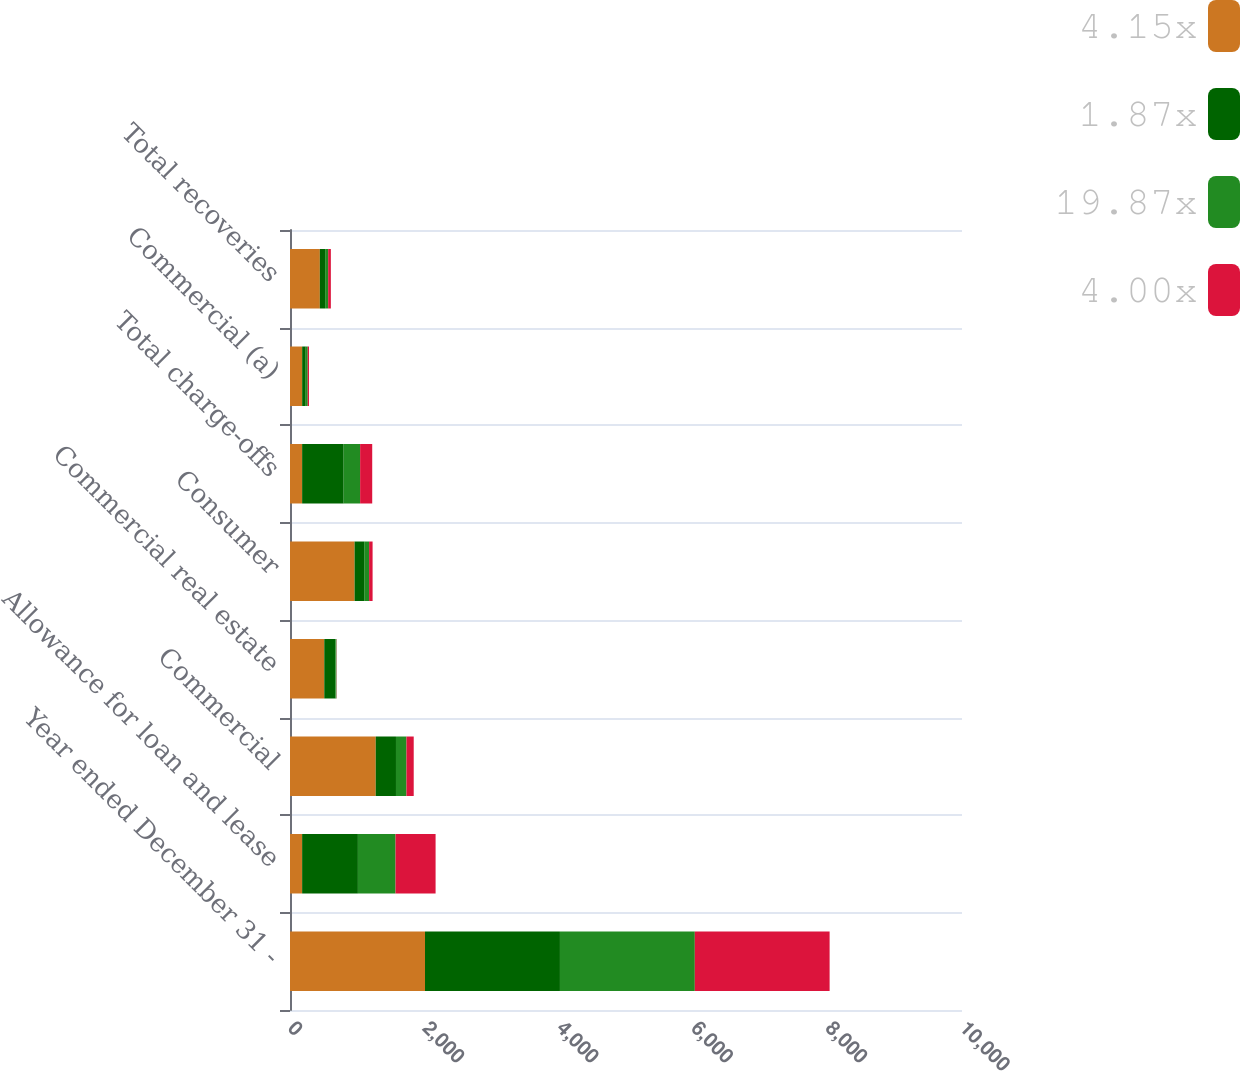Convert chart to OTSL. <chart><loc_0><loc_0><loc_500><loc_500><stacked_bar_chart><ecel><fcel>Year ended December 31 -<fcel>Allowance for loan and lease<fcel>Commercial<fcel>Commercial real estate<fcel>Consumer<fcel>Total charge-offs<fcel>Commercial (a)<fcel>Total recoveries<nl><fcel>4.15x<fcel>2009<fcel>180.5<fcel>1276<fcel>510<fcel>961<fcel>180.5<fcel>181<fcel>444<nl><fcel>1.87x<fcel>2008<fcel>830<fcel>301<fcel>165<fcel>143<fcel>618<fcel>53<fcel>79<nl><fcel>19.87x<fcel>2007<fcel>560<fcel>156<fcel>16<fcel>73<fcel>245<fcel>30<fcel>45<nl><fcel>4.00x<fcel>2006<fcel>596<fcel>108<fcel>3<fcel>52<fcel>180<fcel>19<fcel>40<nl></chart> 